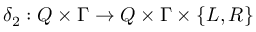Convert formula to latex. <formula><loc_0><loc_0><loc_500><loc_500>\delta _ { 2 } \colon Q \times \Gamma \to Q \times \Gamma \times \{ L , R \}</formula> 